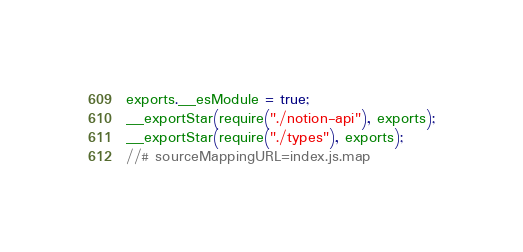Convert code to text. <code><loc_0><loc_0><loc_500><loc_500><_JavaScript_>exports.__esModule = true;
__exportStar(require("./notion-api"), exports);
__exportStar(require("./types"), exports);
//# sourceMappingURL=index.js.map</code> 